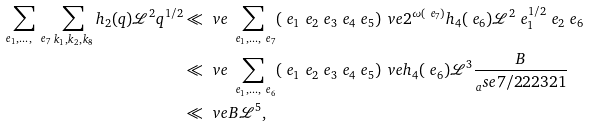<formula> <loc_0><loc_0><loc_500><loc_500>\sum _ { \ e _ { 1 } , \dots , \ e _ { 7 } } \sum _ { k _ { 1 } , k _ { 2 } , k _ { 8 } } h _ { 2 } ( q ) \mathcal { L } ^ { 2 } q ^ { 1 / 2 } & \ll _ { \ } v e \sum _ { \ e _ { 1 } , \dots , \ e _ { 7 } } ( \ e _ { 1 } \ e _ { 2 } \ e _ { 3 } \ e _ { 4 } \ e _ { 5 } ) ^ { \ } v e 2 ^ { \omega ( \ e _ { 7 } ) } h _ { 4 } ( \ e _ { 6 } ) \mathcal { L } ^ { 2 } \ e _ { 1 } ^ { 1 / 2 } \ e _ { 2 } \ e _ { 6 } \\ & \ll _ { \ } v e \sum _ { \ e _ { 1 } , \dots , \ e _ { 6 } } ( \ e _ { 1 } \ e _ { 2 } \ e _ { 3 } \ e _ { 4 } \ e _ { 5 } ) ^ { \ } v e h _ { 4 } ( \ e _ { 6 } ) \mathcal { L } ^ { 3 } \frac { B } { _ { a } s e { 7 / 2 } 2 2 3 2 1 } \\ & \ll _ { \ } v e B \mathcal { L } ^ { 5 } ,</formula> 